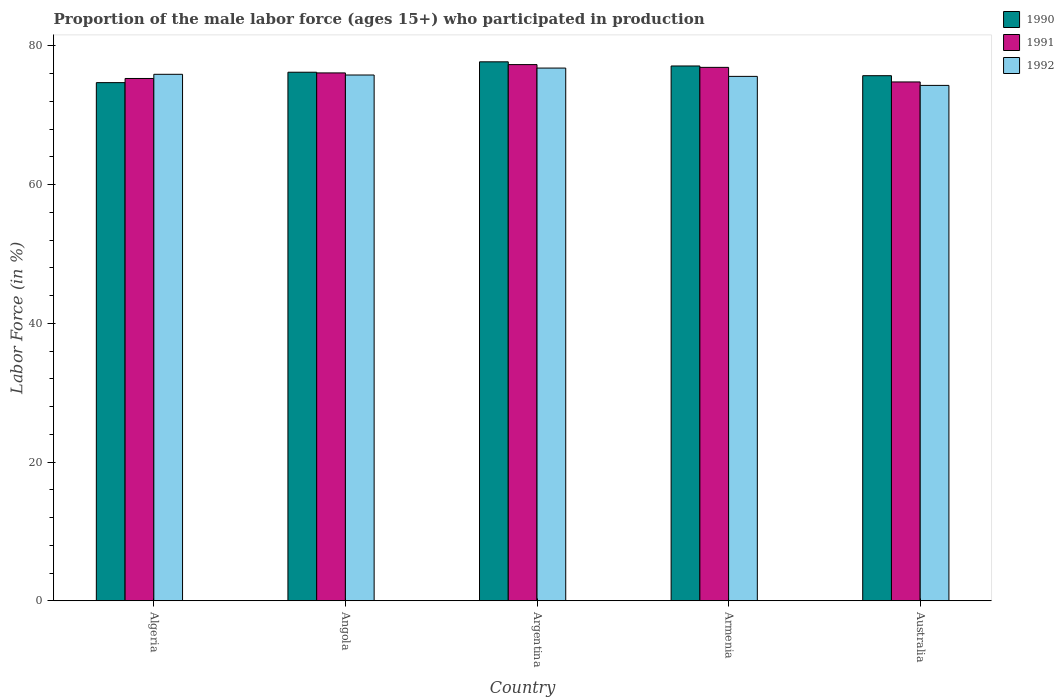How many different coloured bars are there?
Keep it short and to the point. 3. How many groups of bars are there?
Ensure brevity in your answer.  5. Are the number of bars per tick equal to the number of legend labels?
Your answer should be very brief. Yes. How many bars are there on the 3rd tick from the left?
Your answer should be very brief. 3. How many bars are there on the 1st tick from the right?
Make the answer very short. 3. What is the label of the 3rd group of bars from the left?
Keep it short and to the point. Argentina. What is the proportion of the male labor force who participated in production in 1990 in Armenia?
Your answer should be compact. 77.1. Across all countries, what is the maximum proportion of the male labor force who participated in production in 1991?
Offer a very short reply. 77.3. Across all countries, what is the minimum proportion of the male labor force who participated in production in 1992?
Give a very brief answer. 74.3. In which country was the proportion of the male labor force who participated in production in 1990 minimum?
Offer a terse response. Algeria. What is the total proportion of the male labor force who participated in production in 1991 in the graph?
Provide a short and direct response. 380.4. What is the difference between the proportion of the male labor force who participated in production in 1991 in Angola and that in Argentina?
Provide a succinct answer. -1.2. What is the difference between the proportion of the male labor force who participated in production in 1990 in Angola and the proportion of the male labor force who participated in production in 1992 in Algeria?
Give a very brief answer. 0.3. What is the average proportion of the male labor force who participated in production in 1991 per country?
Your answer should be very brief. 76.08. What is the difference between the proportion of the male labor force who participated in production of/in 1992 and proportion of the male labor force who participated in production of/in 1991 in Argentina?
Provide a succinct answer. -0.5. In how many countries, is the proportion of the male labor force who participated in production in 1992 greater than 8 %?
Keep it short and to the point. 5. What is the ratio of the proportion of the male labor force who participated in production in 1990 in Algeria to that in Australia?
Your answer should be very brief. 0.99. Is the proportion of the male labor force who participated in production in 1990 in Algeria less than that in Angola?
Your answer should be compact. Yes. Is the difference between the proportion of the male labor force who participated in production in 1992 in Angola and Argentina greater than the difference between the proportion of the male labor force who participated in production in 1991 in Angola and Argentina?
Your response must be concise. Yes. What is the difference between the highest and the second highest proportion of the male labor force who participated in production in 1990?
Offer a terse response. -0.6. What is the difference between the highest and the lowest proportion of the male labor force who participated in production in 1991?
Make the answer very short. 2.5. Is the sum of the proportion of the male labor force who participated in production in 1990 in Armenia and Australia greater than the maximum proportion of the male labor force who participated in production in 1991 across all countries?
Keep it short and to the point. Yes. Is it the case that in every country, the sum of the proportion of the male labor force who participated in production in 1991 and proportion of the male labor force who participated in production in 1992 is greater than the proportion of the male labor force who participated in production in 1990?
Offer a very short reply. Yes. Are all the bars in the graph horizontal?
Offer a terse response. No. What is the difference between two consecutive major ticks on the Y-axis?
Your answer should be very brief. 20. Does the graph contain any zero values?
Provide a short and direct response. No. How many legend labels are there?
Offer a terse response. 3. What is the title of the graph?
Make the answer very short. Proportion of the male labor force (ages 15+) who participated in production. What is the Labor Force (in %) in 1990 in Algeria?
Your answer should be very brief. 74.7. What is the Labor Force (in %) of 1991 in Algeria?
Keep it short and to the point. 75.3. What is the Labor Force (in %) of 1992 in Algeria?
Offer a terse response. 75.9. What is the Labor Force (in %) in 1990 in Angola?
Provide a short and direct response. 76.2. What is the Labor Force (in %) in 1991 in Angola?
Your response must be concise. 76.1. What is the Labor Force (in %) of 1992 in Angola?
Ensure brevity in your answer.  75.8. What is the Labor Force (in %) in 1990 in Argentina?
Make the answer very short. 77.7. What is the Labor Force (in %) of 1991 in Argentina?
Provide a succinct answer. 77.3. What is the Labor Force (in %) in 1992 in Argentina?
Provide a short and direct response. 76.8. What is the Labor Force (in %) of 1990 in Armenia?
Your answer should be very brief. 77.1. What is the Labor Force (in %) in 1991 in Armenia?
Provide a succinct answer. 76.9. What is the Labor Force (in %) of 1992 in Armenia?
Provide a succinct answer. 75.6. What is the Labor Force (in %) in 1990 in Australia?
Make the answer very short. 75.7. What is the Labor Force (in %) in 1991 in Australia?
Offer a very short reply. 74.8. What is the Labor Force (in %) of 1992 in Australia?
Provide a succinct answer. 74.3. Across all countries, what is the maximum Labor Force (in %) in 1990?
Give a very brief answer. 77.7. Across all countries, what is the maximum Labor Force (in %) in 1991?
Give a very brief answer. 77.3. Across all countries, what is the maximum Labor Force (in %) in 1992?
Provide a short and direct response. 76.8. Across all countries, what is the minimum Labor Force (in %) in 1990?
Provide a succinct answer. 74.7. Across all countries, what is the minimum Labor Force (in %) of 1991?
Your answer should be compact. 74.8. Across all countries, what is the minimum Labor Force (in %) of 1992?
Keep it short and to the point. 74.3. What is the total Labor Force (in %) in 1990 in the graph?
Provide a succinct answer. 381.4. What is the total Labor Force (in %) in 1991 in the graph?
Offer a terse response. 380.4. What is the total Labor Force (in %) of 1992 in the graph?
Your response must be concise. 378.4. What is the difference between the Labor Force (in %) in 1992 in Algeria and that in Angola?
Provide a succinct answer. 0.1. What is the difference between the Labor Force (in %) of 1990 in Algeria and that in Argentina?
Keep it short and to the point. -3. What is the difference between the Labor Force (in %) of 1991 in Algeria and that in Argentina?
Your answer should be very brief. -2. What is the difference between the Labor Force (in %) of 1992 in Algeria and that in Argentina?
Make the answer very short. -0.9. What is the difference between the Labor Force (in %) of 1990 in Algeria and that in Armenia?
Your response must be concise. -2.4. What is the difference between the Labor Force (in %) in 1991 in Algeria and that in Armenia?
Make the answer very short. -1.6. What is the difference between the Labor Force (in %) in 1992 in Algeria and that in Armenia?
Provide a succinct answer. 0.3. What is the difference between the Labor Force (in %) of 1990 in Algeria and that in Australia?
Offer a very short reply. -1. What is the difference between the Labor Force (in %) of 1991 in Algeria and that in Australia?
Make the answer very short. 0.5. What is the difference between the Labor Force (in %) in 1990 in Angola and that in Argentina?
Make the answer very short. -1.5. What is the difference between the Labor Force (in %) in 1992 in Angola and that in Argentina?
Your response must be concise. -1. What is the difference between the Labor Force (in %) of 1991 in Angola and that in Armenia?
Your answer should be very brief. -0.8. What is the difference between the Labor Force (in %) in 1991 in Angola and that in Australia?
Provide a succinct answer. 1.3. What is the difference between the Labor Force (in %) of 1992 in Angola and that in Australia?
Keep it short and to the point. 1.5. What is the difference between the Labor Force (in %) in 1990 in Argentina and that in Armenia?
Provide a succinct answer. 0.6. What is the difference between the Labor Force (in %) in 1991 in Argentina and that in Armenia?
Your answer should be compact. 0.4. What is the difference between the Labor Force (in %) of 1991 in Argentina and that in Australia?
Give a very brief answer. 2.5. What is the difference between the Labor Force (in %) in 1992 in Argentina and that in Australia?
Keep it short and to the point. 2.5. What is the difference between the Labor Force (in %) of 1992 in Armenia and that in Australia?
Provide a succinct answer. 1.3. What is the difference between the Labor Force (in %) of 1990 in Algeria and the Labor Force (in %) of 1991 in Angola?
Give a very brief answer. -1.4. What is the difference between the Labor Force (in %) of 1990 in Algeria and the Labor Force (in %) of 1991 in Argentina?
Give a very brief answer. -2.6. What is the difference between the Labor Force (in %) in 1990 in Algeria and the Labor Force (in %) in 1992 in Argentina?
Offer a very short reply. -2.1. What is the difference between the Labor Force (in %) in 1991 in Algeria and the Labor Force (in %) in 1992 in Argentina?
Your response must be concise. -1.5. What is the difference between the Labor Force (in %) in 1990 in Algeria and the Labor Force (in %) in 1991 in Armenia?
Give a very brief answer. -2.2. What is the difference between the Labor Force (in %) in 1991 in Algeria and the Labor Force (in %) in 1992 in Armenia?
Offer a terse response. -0.3. What is the difference between the Labor Force (in %) of 1990 in Algeria and the Labor Force (in %) of 1991 in Australia?
Ensure brevity in your answer.  -0.1. What is the difference between the Labor Force (in %) in 1990 in Algeria and the Labor Force (in %) in 1992 in Australia?
Make the answer very short. 0.4. What is the difference between the Labor Force (in %) in 1991 in Algeria and the Labor Force (in %) in 1992 in Australia?
Offer a terse response. 1. What is the difference between the Labor Force (in %) in 1990 in Angola and the Labor Force (in %) in 1991 in Argentina?
Give a very brief answer. -1.1. What is the difference between the Labor Force (in %) of 1990 in Angola and the Labor Force (in %) of 1991 in Australia?
Ensure brevity in your answer.  1.4. What is the difference between the Labor Force (in %) in 1990 in Angola and the Labor Force (in %) in 1992 in Australia?
Provide a short and direct response. 1.9. What is the difference between the Labor Force (in %) in 1991 in Argentina and the Labor Force (in %) in 1992 in Armenia?
Ensure brevity in your answer.  1.7. What is the difference between the Labor Force (in %) of 1990 in Argentina and the Labor Force (in %) of 1991 in Australia?
Provide a succinct answer. 2.9. What is the difference between the Labor Force (in %) of 1990 in Armenia and the Labor Force (in %) of 1991 in Australia?
Provide a short and direct response. 2.3. What is the difference between the Labor Force (in %) of 1990 in Armenia and the Labor Force (in %) of 1992 in Australia?
Your response must be concise. 2.8. What is the difference between the Labor Force (in %) of 1991 in Armenia and the Labor Force (in %) of 1992 in Australia?
Provide a short and direct response. 2.6. What is the average Labor Force (in %) of 1990 per country?
Your answer should be compact. 76.28. What is the average Labor Force (in %) in 1991 per country?
Your answer should be very brief. 76.08. What is the average Labor Force (in %) in 1992 per country?
Offer a very short reply. 75.68. What is the difference between the Labor Force (in %) of 1990 and Labor Force (in %) of 1992 in Algeria?
Your answer should be very brief. -1.2. What is the difference between the Labor Force (in %) in 1990 and Labor Force (in %) in 1992 in Angola?
Provide a succinct answer. 0.4. What is the difference between the Labor Force (in %) in 1991 and Labor Force (in %) in 1992 in Argentina?
Offer a very short reply. 0.5. What is the difference between the Labor Force (in %) in 1991 and Labor Force (in %) in 1992 in Armenia?
Ensure brevity in your answer.  1.3. What is the difference between the Labor Force (in %) of 1990 and Labor Force (in %) of 1991 in Australia?
Provide a short and direct response. 0.9. What is the difference between the Labor Force (in %) of 1990 and Labor Force (in %) of 1992 in Australia?
Keep it short and to the point. 1.4. What is the ratio of the Labor Force (in %) of 1990 in Algeria to that in Angola?
Your response must be concise. 0.98. What is the ratio of the Labor Force (in %) of 1990 in Algeria to that in Argentina?
Provide a short and direct response. 0.96. What is the ratio of the Labor Force (in %) of 1991 in Algeria to that in Argentina?
Offer a very short reply. 0.97. What is the ratio of the Labor Force (in %) of 1992 in Algeria to that in Argentina?
Your answer should be compact. 0.99. What is the ratio of the Labor Force (in %) of 1990 in Algeria to that in Armenia?
Provide a succinct answer. 0.97. What is the ratio of the Labor Force (in %) of 1991 in Algeria to that in Armenia?
Your answer should be compact. 0.98. What is the ratio of the Labor Force (in %) of 1992 in Algeria to that in Armenia?
Give a very brief answer. 1. What is the ratio of the Labor Force (in %) of 1990 in Algeria to that in Australia?
Your answer should be compact. 0.99. What is the ratio of the Labor Force (in %) in 1991 in Algeria to that in Australia?
Your answer should be compact. 1.01. What is the ratio of the Labor Force (in %) in 1992 in Algeria to that in Australia?
Offer a very short reply. 1.02. What is the ratio of the Labor Force (in %) of 1990 in Angola to that in Argentina?
Make the answer very short. 0.98. What is the ratio of the Labor Force (in %) of 1991 in Angola to that in Argentina?
Keep it short and to the point. 0.98. What is the ratio of the Labor Force (in %) in 1990 in Angola to that in Armenia?
Provide a succinct answer. 0.99. What is the ratio of the Labor Force (in %) of 1992 in Angola to that in Armenia?
Offer a terse response. 1. What is the ratio of the Labor Force (in %) in 1990 in Angola to that in Australia?
Offer a very short reply. 1.01. What is the ratio of the Labor Force (in %) of 1991 in Angola to that in Australia?
Offer a very short reply. 1.02. What is the ratio of the Labor Force (in %) of 1992 in Angola to that in Australia?
Keep it short and to the point. 1.02. What is the ratio of the Labor Force (in %) of 1990 in Argentina to that in Armenia?
Ensure brevity in your answer.  1.01. What is the ratio of the Labor Force (in %) of 1992 in Argentina to that in Armenia?
Provide a succinct answer. 1.02. What is the ratio of the Labor Force (in %) of 1990 in Argentina to that in Australia?
Keep it short and to the point. 1.03. What is the ratio of the Labor Force (in %) in 1991 in Argentina to that in Australia?
Ensure brevity in your answer.  1.03. What is the ratio of the Labor Force (in %) of 1992 in Argentina to that in Australia?
Your response must be concise. 1.03. What is the ratio of the Labor Force (in %) of 1990 in Armenia to that in Australia?
Your answer should be compact. 1.02. What is the ratio of the Labor Force (in %) in 1991 in Armenia to that in Australia?
Provide a succinct answer. 1.03. What is the ratio of the Labor Force (in %) in 1992 in Armenia to that in Australia?
Provide a succinct answer. 1.02. What is the difference between the highest and the second highest Labor Force (in %) of 1990?
Ensure brevity in your answer.  0.6. What is the difference between the highest and the second highest Labor Force (in %) of 1992?
Your answer should be compact. 0.9. What is the difference between the highest and the lowest Labor Force (in %) of 1991?
Ensure brevity in your answer.  2.5. What is the difference between the highest and the lowest Labor Force (in %) in 1992?
Ensure brevity in your answer.  2.5. 